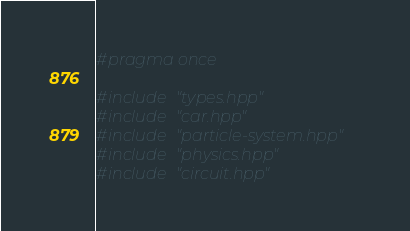<code> <loc_0><loc_0><loc_500><loc_500><_C++_>#pragma once

#include "types.hpp"
#include "car.hpp"
#include "particle-system.hpp"
#include "physics.hpp"
#include "circuit.hpp"</code> 